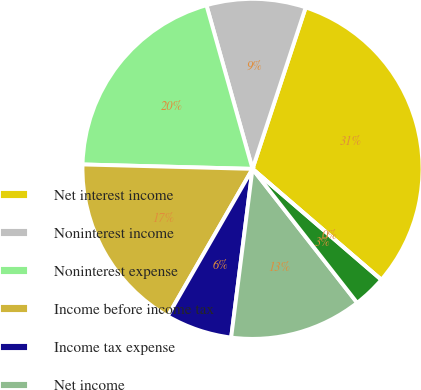<chart> <loc_0><loc_0><loc_500><loc_500><pie_chart><fcel>Net interest income<fcel>Noninterest income<fcel>Noninterest expense<fcel>Income before income tax<fcel>Income tax expense<fcel>Net income<fcel>Basic earnings per share<fcel>Diluted earnings per share<nl><fcel>31.25%<fcel>9.43%<fcel>20.22%<fcel>17.1%<fcel>6.31%<fcel>12.56%<fcel>3.13%<fcel>0.0%<nl></chart> 